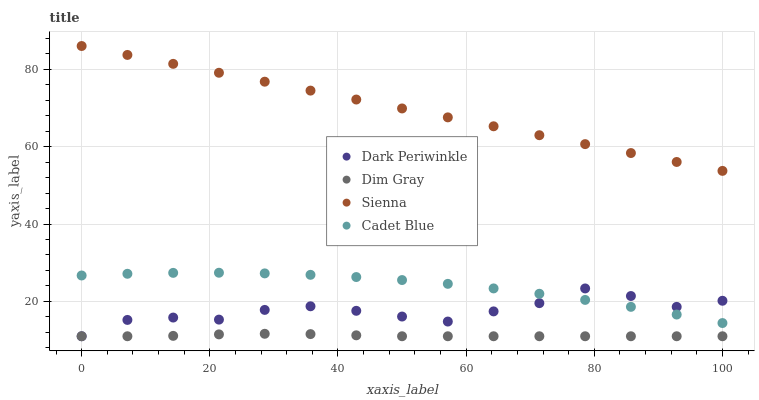Does Dim Gray have the minimum area under the curve?
Answer yes or no. Yes. Does Sienna have the maximum area under the curve?
Answer yes or no. Yes. Does Cadet Blue have the minimum area under the curve?
Answer yes or no. No. Does Cadet Blue have the maximum area under the curve?
Answer yes or no. No. Is Sienna the smoothest?
Answer yes or no. Yes. Is Dark Periwinkle the roughest?
Answer yes or no. Yes. Is Dim Gray the smoothest?
Answer yes or no. No. Is Dim Gray the roughest?
Answer yes or no. No. Does Dim Gray have the lowest value?
Answer yes or no. Yes. Does Cadet Blue have the lowest value?
Answer yes or no. No. Does Sienna have the highest value?
Answer yes or no. Yes. Does Cadet Blue have the highest value?
Answer yes or no. No. Is Dark Periwinkle less than Sienna?
Answer yes or no. Yes. Is Sienna greater than Dark Periwinkle?
Answer yes or no. Yes. Does Dark Periwinkle intersect Dim Gray?
Answer yes or no. Yes. Is Dark Periwinkle less than Dim Gray?
Answer yes or no. No. Is Dark Periwinkle greater than Dim Gray?
Answer yes or no. No. Does Dark Periwinkle intersect Sienna?
Answer yes or no. No. 